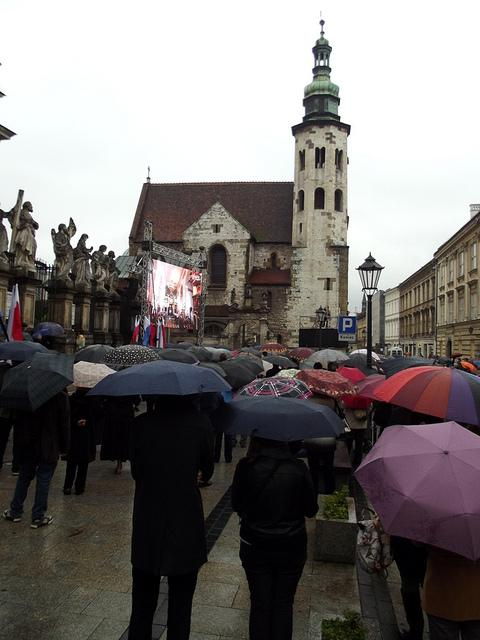Why are the people holding umbrellas? Please explain your reasoning. it's raining. The ground is wet and the people don't want to get wet. 